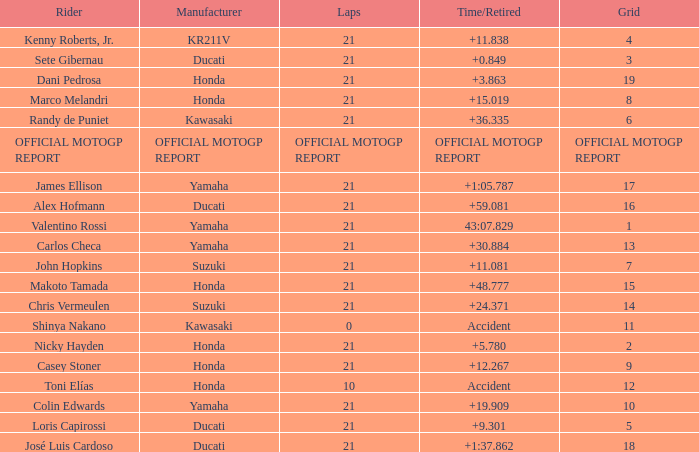When rider John Hopkins had 21 laps, what was the grid? 7.0. 